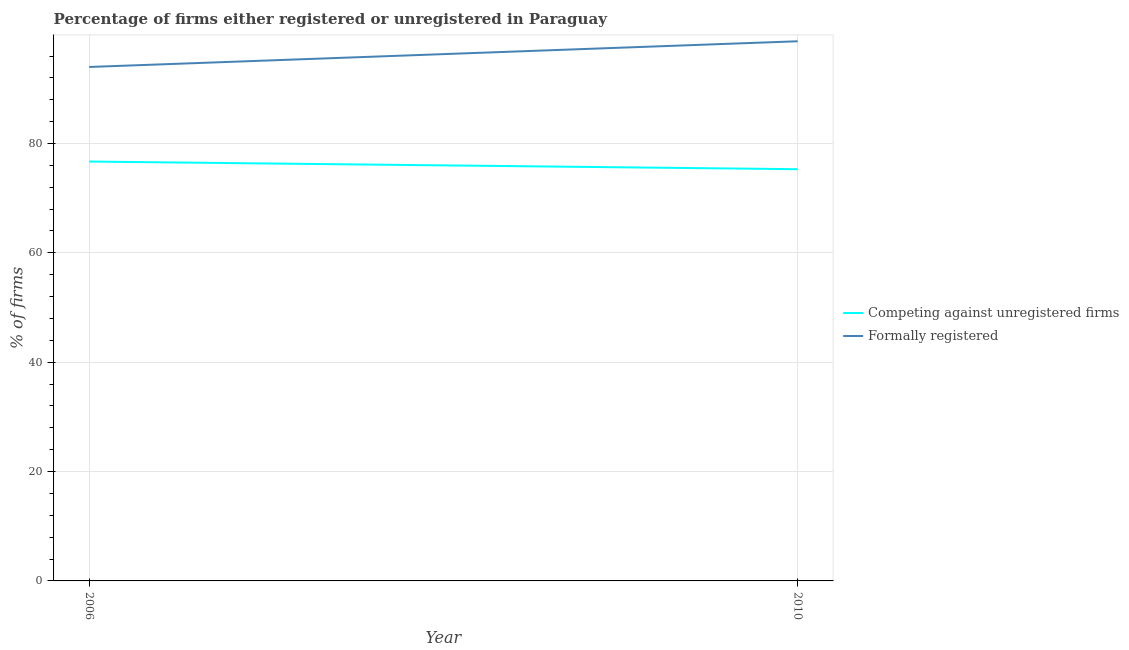How many different coloured lines are there?
Offer a very short reply. 2. Is the number of lines equal to the number of legend labels?
Offer a terse response. Yes. What is the percentage of formally registered firms in 2006?
Your response must be concise. 94. Across all years, what is the maximum percentage of formally registered firms?
Give a very brief answer. 98.7. Across all years, what is the minimum percentage of registered firms?
Your answer should be compact. 75.3. In which year was the percentage of registered firms maximum?
Make the answer very short. 2006. What is the total percentage of registered firms in the graph?
Your answer should be compact. 152. What is the difference between the percentage of registered firms in 2006 and that in 2010?
Give a very brief answer. 1.4. What is the difference between the percentage of formally registered firms in 2006 and the percentage of registered firms in 2010?
Give a very brief answer. 18.7. What is the average percentage of formally registered firms per year?
Offer a very short reply. 96.35. In the year 2010, what is the difference between the percentage of registered firms and percentage of formally registered firms?
Provide a succinct answer. -23.4. In how many years, is the percentage of formally registered firms greater than 60 %?
Your response must be concise. 2. What is the ratio of the percentage of registered firms in 2006 to that in 2010?
Offer a very short reply. 1.02. Is the percentage of registered firms in 2006 less than that in 2010?
Make the answer very short. No. Is the percentage of registered firms strictly greater than the percentage of formally registered firms over the years?
Keep it short and to the point. No. Is the percentage of formally registered firms strictly less than the percentage of registered firms over the years?
Offer a very short reply. No. How many lines are there?
Your answer should be very brief. 2. How many years are there in the graph?
Keep it short and to the point. 2. Are the values on the major ticks of Y-axis written in scientific E-notation?
Make the answer very short. No. Does the graph contain any zero values?
Your answer should be compact. No. What is the title of the graph?
Offer a terse response. Percentage of firms either registered or unregistered in Paraguay. Does "Electricity" appear as one of the legend labels in the graph?
Your answer should be compact. No. What is the label or title of the Y-axis?
Your answer should be compact. % of firms. What is the % of firms of Competing against unregistered firms in 2006?
Your answer should be compact. 76.7. What is the % of firms in Formally registered in 2006?
Offer a terse response. 94. What is the % of firms in Competing against unregistered firms in 2010?
Provide a short and direct response. 75.3. What is the % of firms in Formally registered in 2010?
Your answer should be very brief. 98.7. Across all years, what is the maximum % of firms of Competing against unregistered firms?
Offer a very short reply. 76.7. Across all years, what is the maximum % of firms of Formally registered?
Your response must be concise. 98.7. Across all years, what is the minimum % of firms in Competing against unregistered firms?
Offer a terse response. 75.3. Across all years, what is the minimum % of firms of Formally registered?
Give a very brief answer. 94. What is the total % of firms of Competing against unregistered firms in the graph?
Your answer should be compact. 152. What is the total % of firms of Formally registered in the graph?
Ensure brevity in your answer.  192.7. What is the difference between the % of firms of Competing against unregistered firms in 2006 and that in 2010?
Offer a very short reply. 1.4. What is the difference between the % of firms in Formally registered in 2006 and that in 2010?
Your response must be concise. -4.7. What is the average % of firms of Competing against unregistered firms per year?
Offer a terse response. 76. What is the average % of firms of Formally registered per year?
Your answer should be compact. 96.35. In the year 2006, what is the difference between the % of firms of Competing against unregistered firms and % of firms of Formally registered?
Your answer should be compact. -17.3. In the year 2010, what is the difference between the % of firms of Competing against unregistered firms and % of firms of Formally registered?
Offer a terse response. -23.4. What is the ratio of the % of firms of Competing against unregistered firms in 2006 to that in 2010?
Offer a very short reply. 1.02. What is the ratio of the % of firms of Formally registered in 2006 to that in 2010?
Offer a very short reply. 0.95. What is the difference between the highest and the second highest % of firms of Formally registered?
Your answer should be very brief. 4.7. 